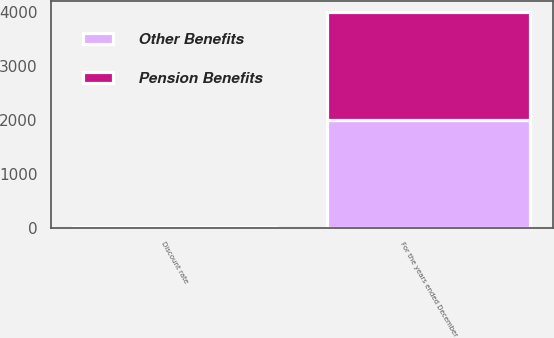Convert chart to OTSL. <chart><loc_0><loc_0><loc_500><loc_500><stacked_bar_chart><ecel><fcel>For the years ended December<fcel>Discount rate<nl><fcel>Other Benefits<fcel>2005<fcel>5.7<nl><fcel>Pension Benefits<fcel>2005<fcel>5.7<nl></chart> 